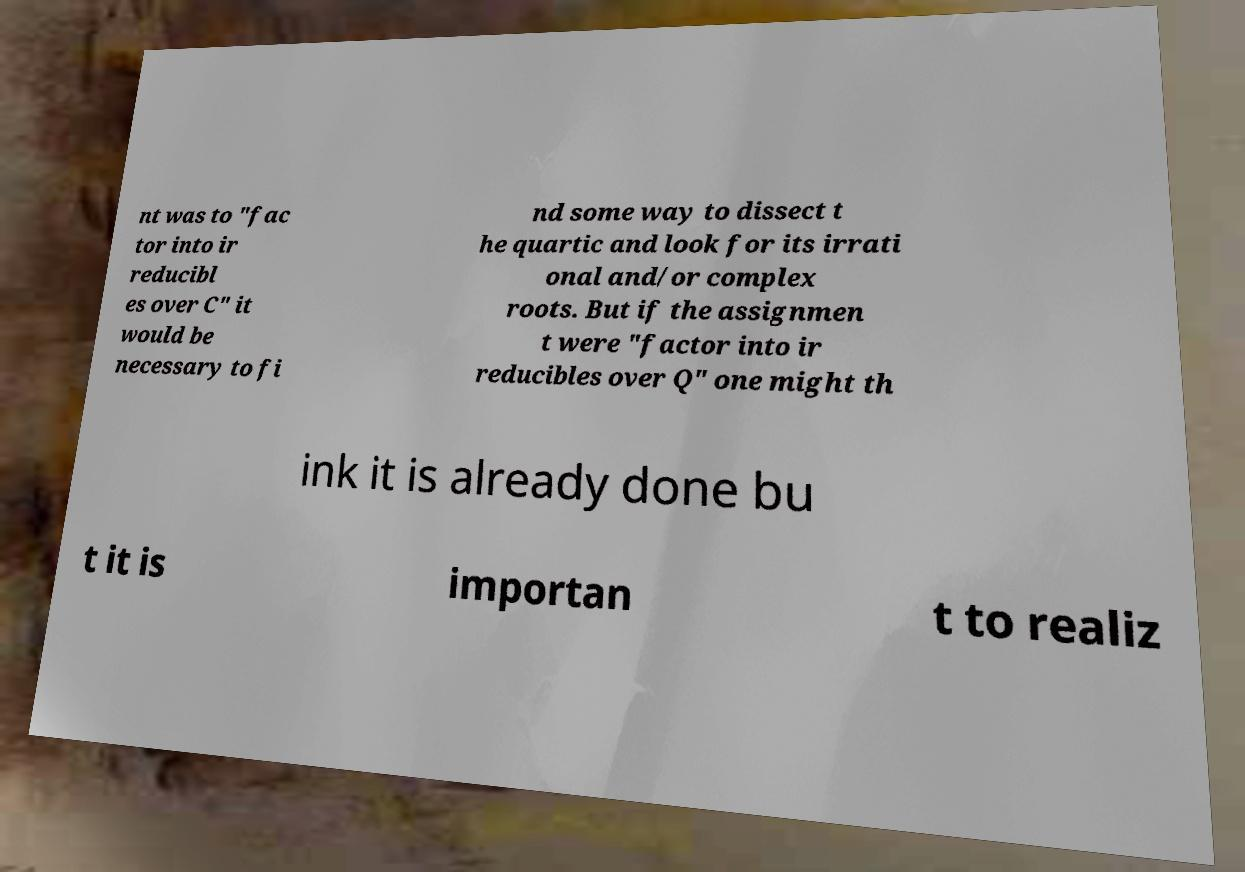Can you accurately transcribe the text from the provided image for me? nt was to "fac tor into ir reducibl es over C" it would be necessary to fi nd some way to dissect t he quartic and look for its irrati onal and/or complex roots. But if the assignmen t were "factor into ir reducibles over Q" one might th ink it is already done bu t it is importan t to realiz 